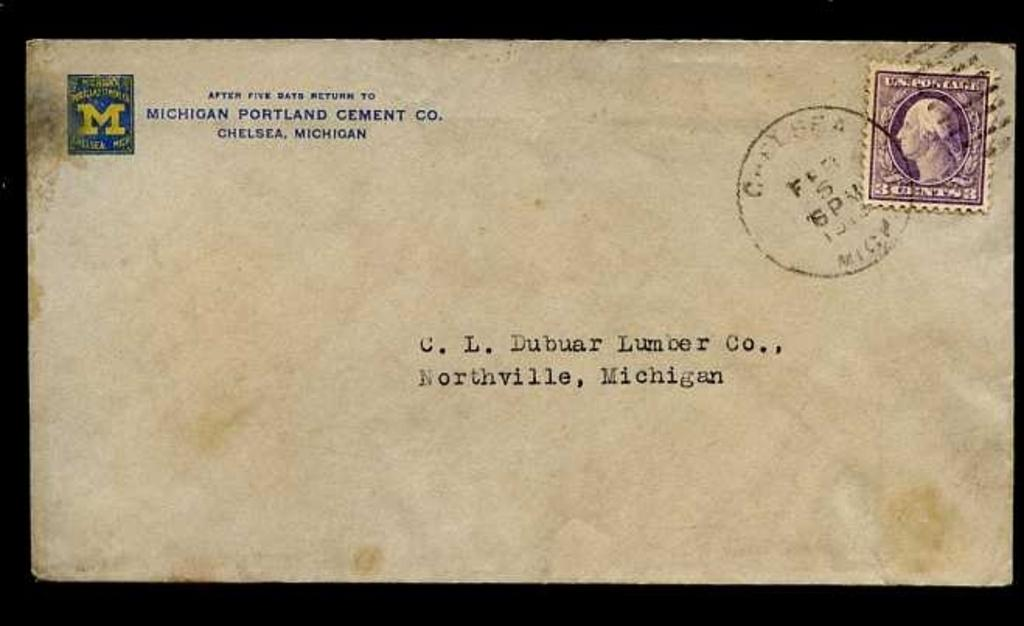<image>
Describe the image concisely. Vintage envelope addressed to C.L. Dubaur Lumber Co., Northville, Michigan from Michigan Portland Cement Co. Chelsea, MI. 